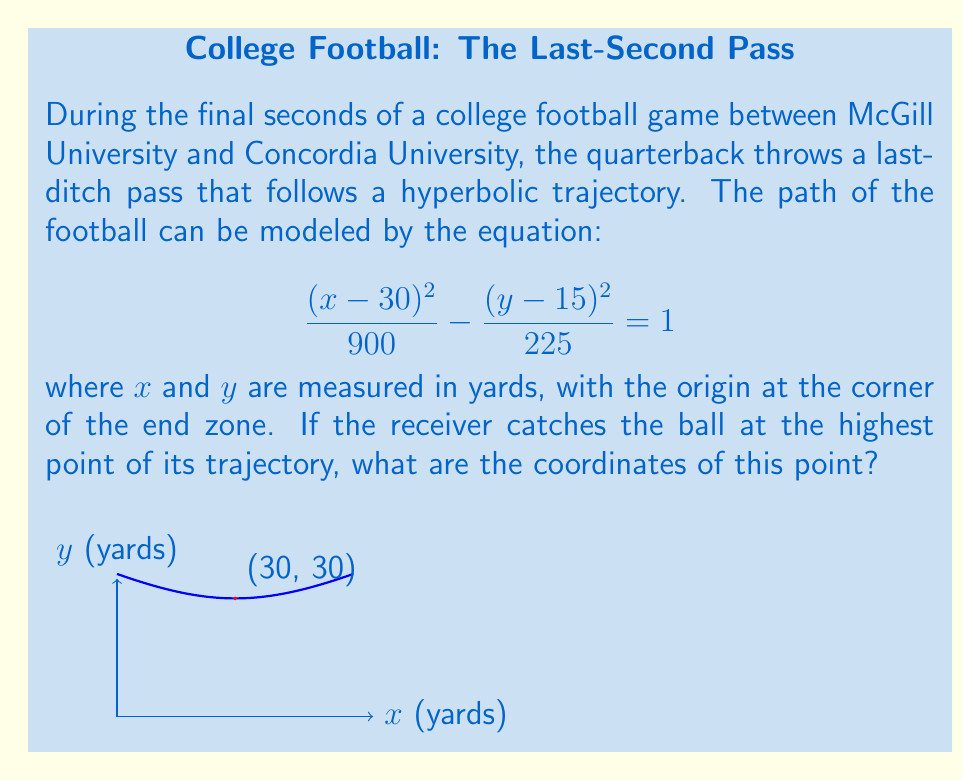What is the answer to this math problem? Let's approach this step-by-step:

1) The equation of the hyperbola is given as:

   $$\frac{(x-30)^2}{900} - \frac{(y-15)^2}{225} = 1$$

2) To find the highest point, we need to find the vertex of the hyperbola. For a hyperbola with this orientation, the vertex will occur at the center point of the hyperbola.

3) From the equation, we can see that the center is at (30, 15). This is because the equation is in the form:

   $$\frac{(x-h)^2}{a^2} - \frac{(y-k)^2}{b^2} = 1$$

   where (h,k) is the center of the hyperbola.

4) However, this is not the highest point of the trajectory. The highest point will be 'a' units above the center point.

5) From the equation, we can see that $a^2 = 900$, so $a = 30$ yards.

6) Therefore, the highest point will be 15 (the y-coordinate of the center) plus 30, which equals 45 yards.

7) The x-coordinate of the highest point will be the same as the x-coordinate of the center, which is 30 yards.

Thus, the coordinates of the highest point are (30, 30).
Answer: (30, 30) 